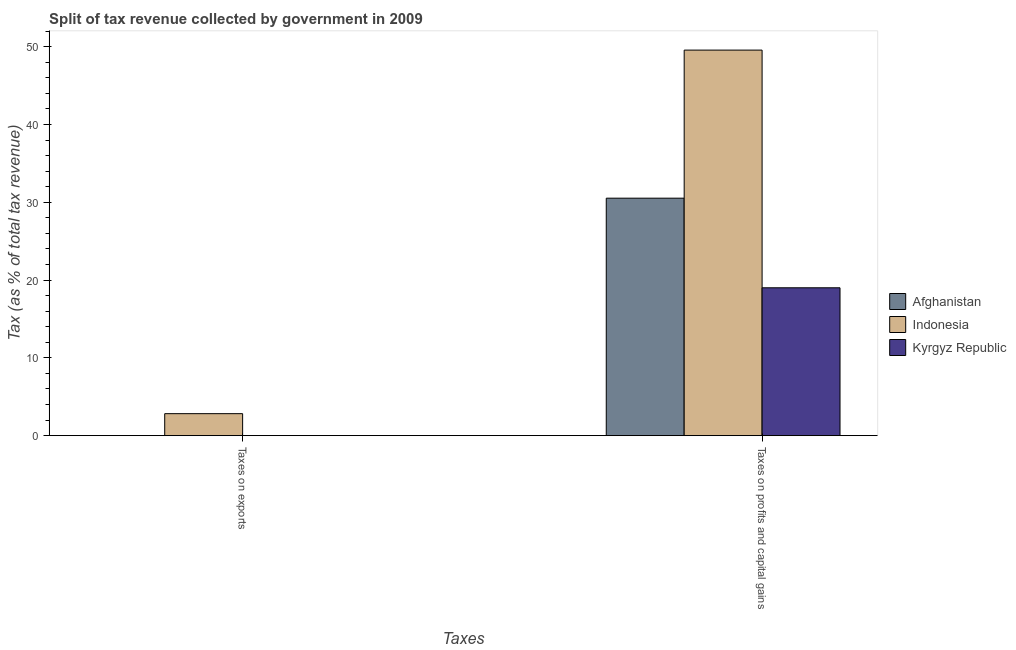Are the number of bars per tick equal to the number of legend labels?
Your response must be concise. Yes. How many bars are there on the 2nd tick from the left?
Give a very brief answer. 3. How many bars are there on the 1st tick from the right?
Ensure brevity in your answer.  3. What is the label of the 1st group of bars from the left?
Give a very brief answer. Taxes on exports. What is the percentage of revenue obtained from taxes on profits and capital gains in Kyrgyz Republic?
Provide a succinct answer. 19.01. Across all countries, what is the maximum percentage of revenue obtained from taxes on exports?
Provide a short and direct response. 2.83. Across all countries, what is the minimum percentage of revenue obtained from taxes on profits and capital gains?
Provide a short and direct response. 19.01. In which country was the percentage of revenue obtained from taxes on profits and capital gains minimum?
Make the answer very short. Kyrgyz Republic. What is the total percentage of revenue obtained from taxes on exports in the graph?
Offer a terse response. 2.85. What is the difference between the percentage of revenue obtained from taxes on exports in Afghanistan and that in Indonesia?
Offer a very short reply. -2.81. What is the difference between the percentage of revenue obtained from taxes on profits and capital gains in Indonesia and the percentage of revenue obtained from taxes on exports in Afghanistan?
Your answer should be very brief. 49.55. What is the average percentage of revenue obtained from taxes on profits and capital gains per country?
Provide a short and direct response. 33.04. What is the difference between the percentage of revenue obtained from taxes on profits and capital gains and percentage of revenue obtained from taxes on exports in Indonesia?
Your answer should be very brief. 46.74. In how many countries, is the percentage of revenue obtained from taxes on profits and capital gains greater than 48 %?
Provide a short and direct response. 1. What is the ratio of the percentage of revenue obtained from taxes on profits and capital gains in Kyrgyz Republic to that in Afghanistan?
Offer a very short reply. 0.62. In how many countries, is the percentage of revenue obtained from taxes on exports greater than the average percentage of revenue obtained from taxes on exports taken over all countries?
Your answer should be very brief. 1. What does the 1st bar from the right in Taxes on profits and capital gains represents?
Your answer should be very brief. Kyrgyz Republic. How many bars are there?
Provide a short and direct response. 6. Are all the bars in the graph horizontal?
Your answer should be compact. No. Does the graph contain any zero values?
Provide a succinct answer. No. Does the graph contain grids?
Provide a short and direct response. No. How are the legend labels stacked?
Provide a succinct answer. Vertical. What is the title of the graph?
Provide a succinct answer. Split of tax revenue collected by government in 2009. What is the label or title of the X-axis?
Give a very brief answer. Taxes. What is the label or title of the Y-axis?
Provide a short and direct response. Tax (as % of total tax revenue). What is the Tax (as % of total tax revenue) in Afghanistan in Taxes on exports?
Your response must be concise. 0.02. What is the Tax (as % of total tax revenue) in Indonesia in Taxes on exports?
Provide a short and direct response. 2.83. What is the Tax (as % of total tax revenue) in Kyrgyz Republic in Taxes on exports?
Make the answer very short. 0.01. What is the Tax (as % of total tax revenue) in Afghanistan in Taxes on profits and capital gains?
Your answer should be compact. 30.53. What is the Tax (as % of total tax revenue) of Indonesia in Taxes on profits and capital gains?
Keep it short and to the point. 49.57. What is the Tax (as % of total tax revenue) of Kyrgyz Republic in Taxes on profits and capital gains?
Give a very brief answer. 19.01. Across all Taxes, what is the maximum Tax (as % of total tax revenue) in Afghanistan?
Make the answer very short. 30.53. Across all Taxes, what is the maximum Tax (as % of total tax revenue) of Indonesia?
Provide a short and direct response. 49.57. Across all Taxes, what is the maximum Tax (as % of total tax revenue) in Kyrgyz Republic?
Your response must be concise. 19.01. Across all Taxes, what is the minimum Tax (as % of total tax revenue) of Afghanistan?
Give a very brief answer. 0.02. Across all Taxes, what is the minimum Tax (as % of total tax revenue) in Indonesia?
Provide a short and direct response. 2.83. Across all Taxes, what is the minimum Tax (as % of total tax revenue) of Kyrgyz Republic?
Keep it short and to the point. 0.01. What is the total Tax (as % of total tax revenue) of Afghanistan in the graph?
Provide a succinct answer. 30.55. What is the total Tax (as % of total tax revenue) of Indonesia in the graph?
Provide a short and direct response. 52.39. What is the total Tax (as % of total tax revenue) of Kyrgyz Republic in the graph?
Make the answer very short. 19.02. What is the difference between the Tax (as % of total tax revenue) of Afghanistan in Taxes on exports and that in Taxes on profits and capital gains?
Offer a terse response. -30.51. What is the difference between the Tax (as % of total tax revenue) in Indonesia in Taxes on exports and that in Taxes on profits and capital gains?
Your answer should be compact. -46.74. What is the difference between the Tax (as % of total tax revenue) of Kyrgyz Republic in Taxes on exports and that in Taxes on profits and capital gains?
Your response must be concise. -19. What is the difference between the Tax (as % of total tax revenue) of Afghanistan in Taxes on exports and the Tax (as % of total tax revenue) of Indonesia in Taxes on profits and capital gains?
Provide a succinct answer. -49.55. What is the difference between the Tax (as % of total tax revenue) of Afghanistan in Taxes on exports and the Tax (as % of total tax revenue) of Kyrgyz Republic in Taxes on profits and capital gains?
Your response must be concise. -18.99. What is the difference between the Tax (as % of total tax revenue) of Indonesia in Taxes on exports and the Tax (as % of total tax revenue) of Kyrgyz Republic in Taxes on profits and capital gains?
Offer a very short reply. -16.19. What is the average Tax (as % of total tax revenue) of Afghanistan per Taxes?
Offer a terse response. 15.27. What is the average Tax (as % of total tax revenue) in Indonesia per Taxes?
Provide a short and direct response. 26.2. What is the average Tax (as % of total tax revenue) of Kyrgyz Republic per Taxes?
Provide a succinct answer. 9.51. What is the difference between the Tax (as % of total tax revenue) of Afghanistan and Tax (as % of total tax revenue) of Indonesia in Taxes on exports?
Your answer should be very brief. -2.81. What is the difference between the Tax (as % of total tax revenue) of Afghanistan and Tax (as % of total tax revenue) of Kyrgyz Republic in Taxes on exports?
Your response must be concise. 0.01. What is the difference between the Tax (as % of total tax revenue) in Indonesia and Tax (as % of total tax revenue) in Kyrgyz Republic in Taxes on exports?
Provide a succinct answer. 2.81. What is the difference between the Tax (as % of total tax revenue) of Afghanistan and Tax (as % of total tax revenue) of Indonesia in Taxes on profits and capital gains?
Make the answer very short. -19.04. What is the difference between the Tax (as % of total tax revenue) in Afghanistan and Tax (as % of total tax revenue) in Kyrgyz Republic in Taxes on profits and capital gains?
Your response must be concise. 11.52. What is the difference between the Tax (as % of total tax revenue) of Indonesia and Tax (as % of total tax revenue) of Kyrgyz Republic in Taxes on profits and capital gains?
Your response must be concise. 30.56. What is the ratio of the Tax (as % of total tax revenue) of Afghanistan in Taxes on exports to that in Taxes on profits and capital gains?
Provide a succinct answer. 0. What is the ratio of the Tax (as % of total tax revenue) in Indonesia in Taxes on exports to that in Taxes on profits and capital gains?
Your answer should be compact. 0.06. What is the ratio of the Tax (as % of total tax revenue) in Kyrgyz Republic in Taxes on exports to that in Taxes on profits and capital gains?
Keep it short and to the point. 0. What is the difference between the highest and the second highest Tax (as % of total tax revenue) of Afghanistan?
Make the answer very short. 30.51. What is the difference between the highest and the second highest Tax (as % of total tax revenue) of Indonesia?
Your answer should be very brief. 46.74. What is the difference between the highest and the second highest Tax (as % of total tax revenue) of Kyrgyz Republic?
Provide a short and direct response. 19. What is the difference between the highest and the lowest Tax (as % of total tax revenue) of Afghanistan?
Make the answer very short. 30.51. What is the difference between the highest and the lowest Tax (as % of total tax revenue) of Indonesia?
Provide a short and direct response. 46.74. What is the difference between the highest and the lowest Tax (as % of total tax revenue) of Kyrgyz Republic?
Your response must be concise. 19. 